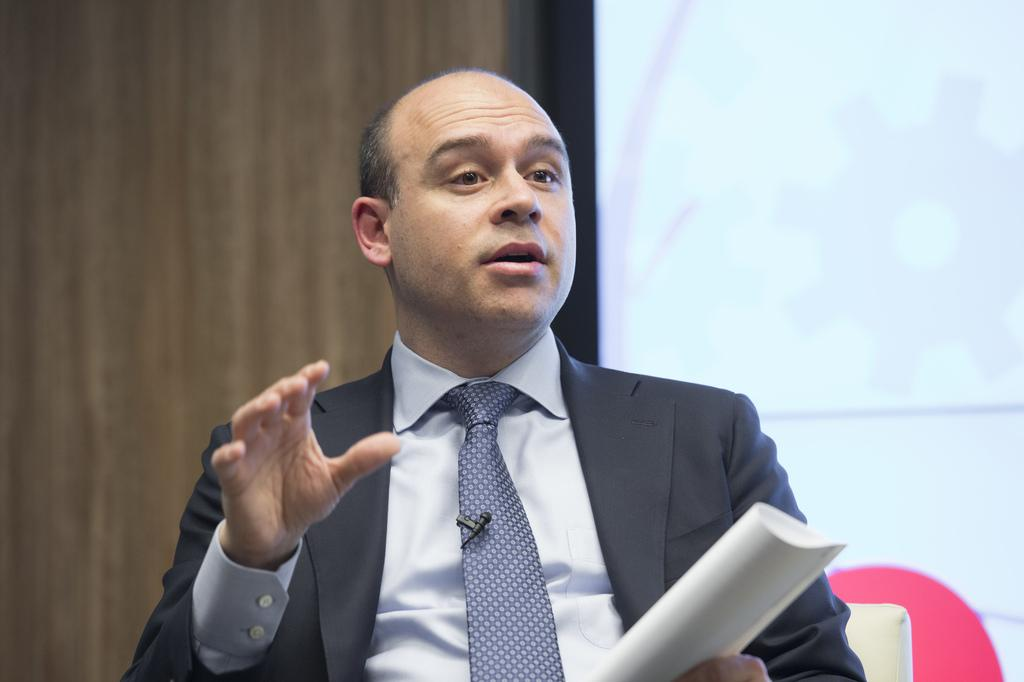What is the main subject of the image? There is a person in the image. What is the person wearing? The person is wearing a suit. Can you describe any accessories the person has? The person has a microphone attached to their tie. What can be seen in the background of the image? There is a wooden wall and a screen in the background of the image. What type of crib is visible in the image? There is no crib present in the image. What industry is the person working in, as indicated by the wooden wall and screen in the background? The image does not provide enough information to determine the industry the person is working in. 